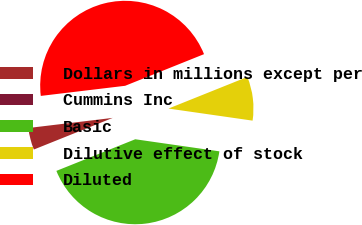Convert chart. <chart><loc_0><loc_0><loc_500><loc_500><pie_chart><fcel>Dollars in millions except per<fcel>Cummins Inc<fcel>Basic<fcel>Dilutive effect of stock<fcel>Diluted<nl><fcel>4.17%<fcel>0.0%<fcel>41.66%<fcel>8.34%<fcel>45.83%<nl></chart> 